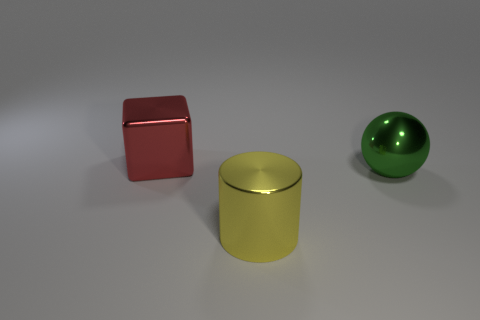Add 3 big shiny cylinders. How many objects exist? 6 Subtract 1 spheres. How many spheres are left? 0 Subtract all yellow balls. How many yellow cubes are left? 0 Subtract all cubes. How many objects are left? 2 Subtract all green spheres. Subtract all cubes. How many objects are left? 1 Add 2 blocks. How many blocks are left? 3 Add 3 big metallic cylinders. How many big metallic cylinders exist? 4 Subtract 0 red balls. How many objects are left? 3 Subtract all blue cylinders. Subtract all purple blocks. How many cylinders are left? 1 